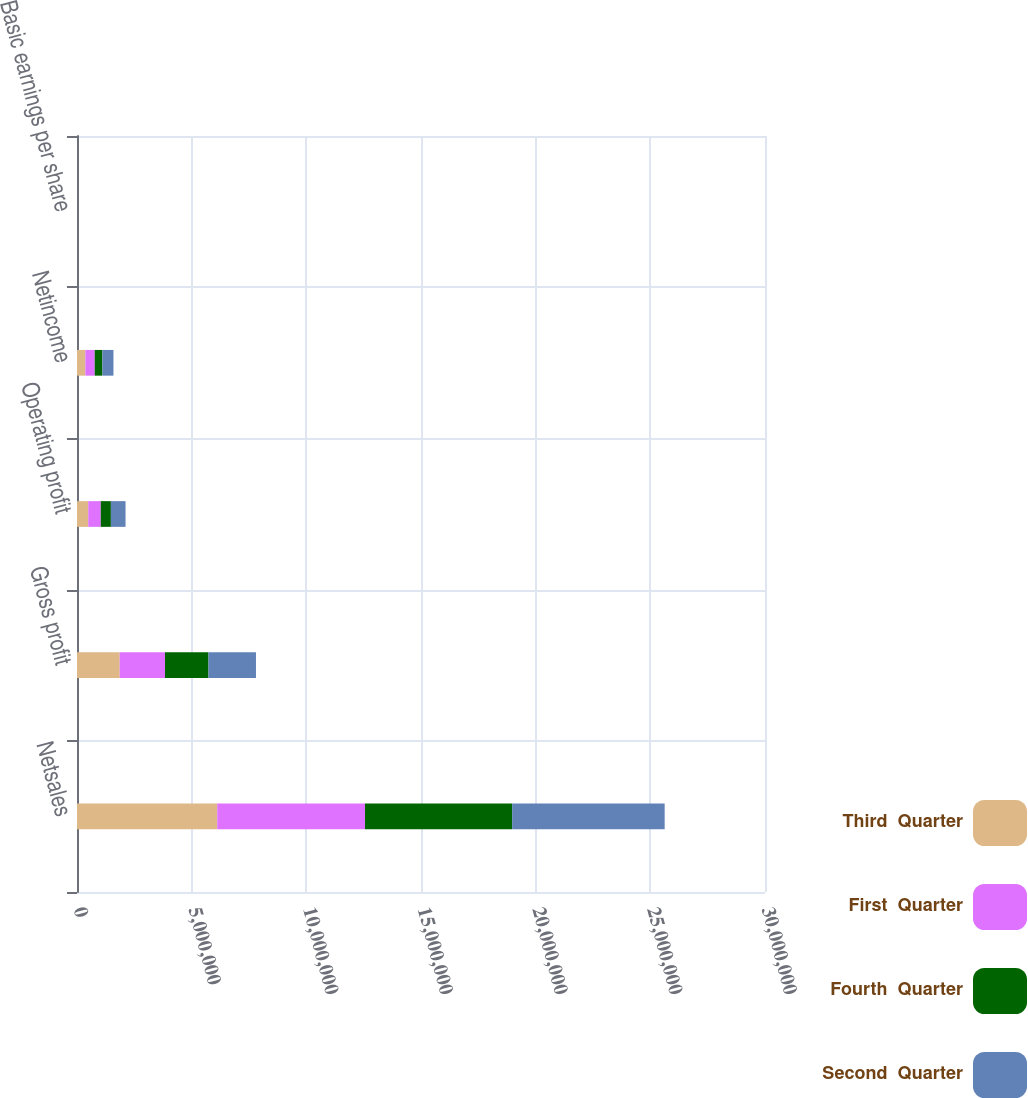<chart> <loc_0><loc_0><loc_500><loc_500><stacked_bar_chart><ecel><fcel>Netsales<fcel>Gross profit<fcel>Operating profit<fcel>Netincome<fcel>Basic earnings per share<nl><fcel>Third  Quarter<fcel>6.11446e+06<fcel>1.86225e+06<fcel>490184<fcel>364852<fcel>1.36<nl><fcel>First  Quarter<fcel>6.44331e+06<fcel>1.97487e+06<fcel>545476<fcel>407237<fcel>1.53<nl><fcel>Fourth  Quarter<fcel>6.41746e+06<fcel>1.89506e+06<fcel>442143<fcel>334142<fcel>1.26<nl><fcel>Second  Quarter<fcel>6.64981e+06<fcel>2.07169e+06<fcel>638503<fcel>483241<fcel>1.85<nl></chart> 